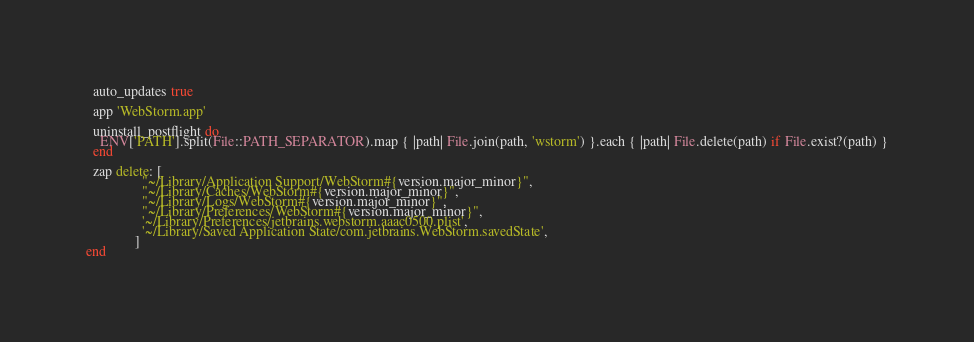<code> <loc_0><loc_0><loc_500><loc_500><_Ruby_>  auto_updates true

  app 'WebStorm.app'

  uninstall_postflight do
    ENV['PATH'].split(File::PATH_SEPARATOR).map { |path| File.join(path, 'wstorm') }.each { |path| File.delete(path) if File.exist?(path) }
  end

  zap delete: [
                "~/Library/Application Support/WebStorm#{version.major_minor}",
                "~/Library/Caches/WebStorm#{version.major_minor}",
                "~/Library/Logs/WebStorm#{version.major_minor}",
                "~/Library/Preferences/WebStorm#{version.major_minor}",
                '~/Library/Preferences/jetbrains.webstorm.aaac0500.plist',
                '~/Library/Saved Application State/com.jetbrains.WebStorm.savedState',
              ]
end
</code> 